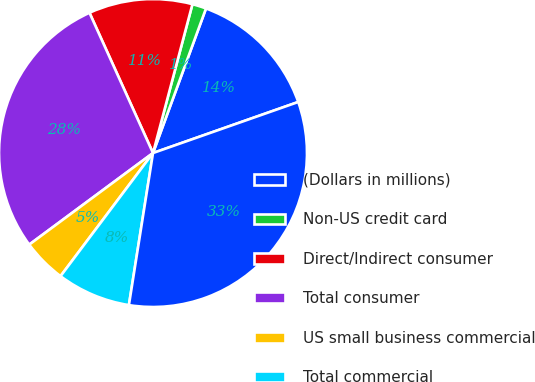Convert chart to OTSL. <chart><loc_0><loc_0><loc_500><loc_500><pie_chart><fcel>(Dollars in millions)<fcel>Non-US credit card<fcel>Direct/Indirect consumer<fcel>Total consumer<fcel>US small business commercial<fcel>Total commercial<fcel>Total renegotiated TDR loans<nl><fcel>14.03%<fcel>1.47%<fcel>10.89%<fcel>28.37%<fcel>4.61%<fcel>7.75%<fcel>32.88%<nl></chart> 